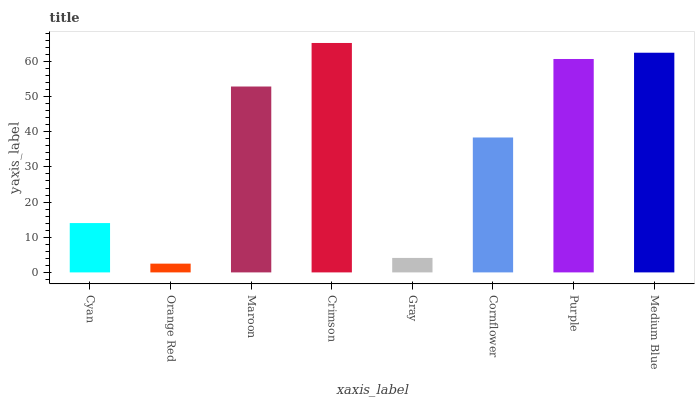Is Orange Red the minimum?
Answer yes or no. Yes. Is Crimson the maximum?
Answer yes or no. Yes. Is Maroon the minimum?
Answer yes or no. No. Is Maroon the maximum?
Answer yes or no. No. Is Maroon greater than Orange Red?
Answer yes or no. Yes. Is Orange Red less than Maroon?
Answer yes or no. Yes. Is Orange Red greater than Maroon?
Answer yes or no. No. Is Maroon less than Orange Red?
Answer yes or no. No. Is Maroon the high median?
Answer yes or no. Yes. Is Cornflower the low median?
Answer yes or no. Yes. Is Gray the high median?
Answer yes or no. No. Is Medium Blue the low median?
Answer yes or no. No. 